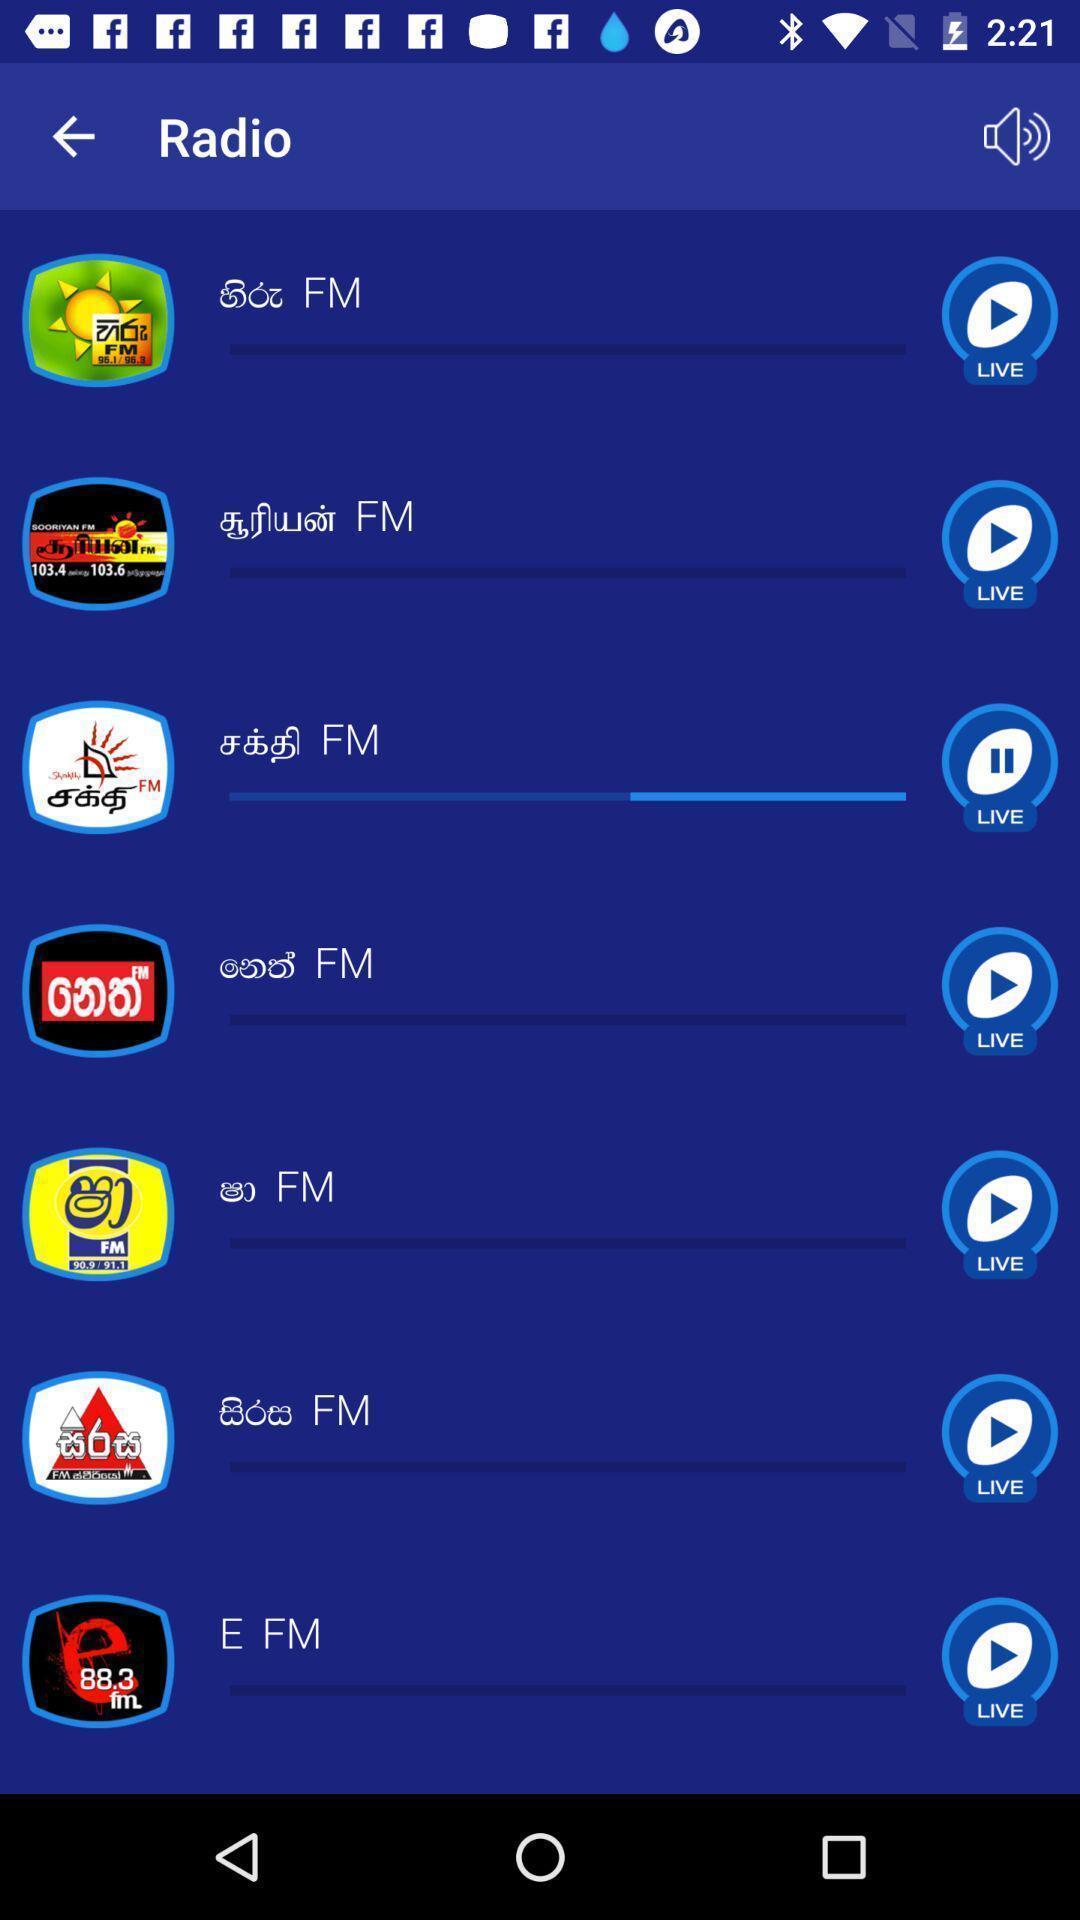Describe the visual elements of this screenshot. Screen showing about mobile ott mobile television app. 